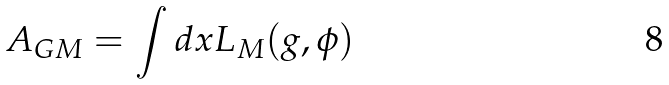<formula> <loc_0><loc_0><loc_500><loc_500>A _ { G M } = \int d x L _ { M } ( g , \phi )</formula> 